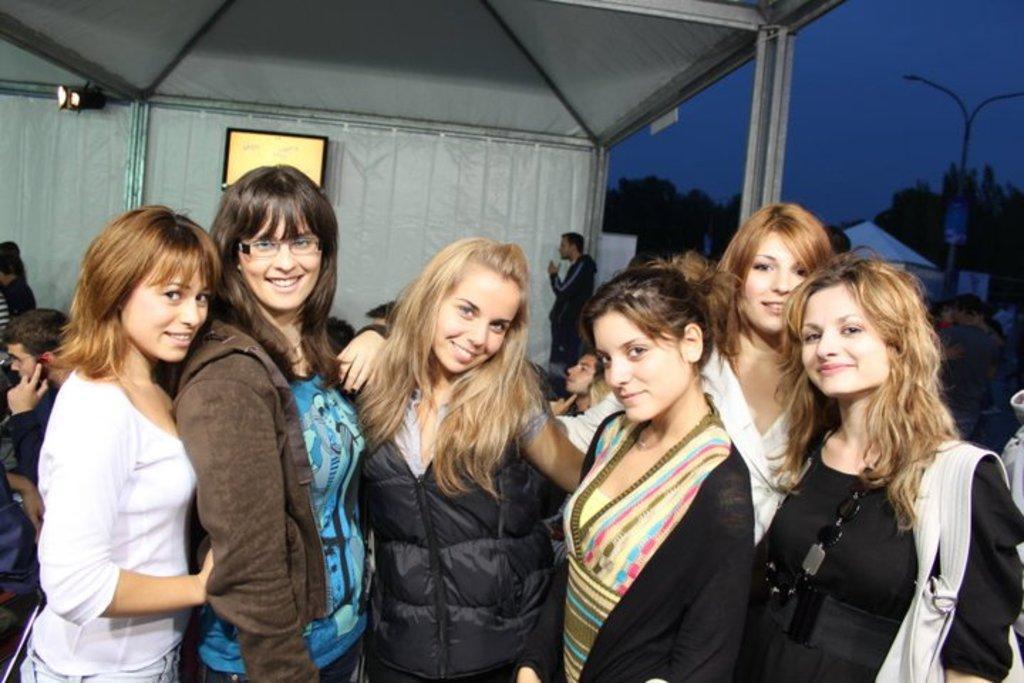Describe this image in one or two sentences. In this image there are people standing under a tent, in the background there are trees, light pole and the sky. 